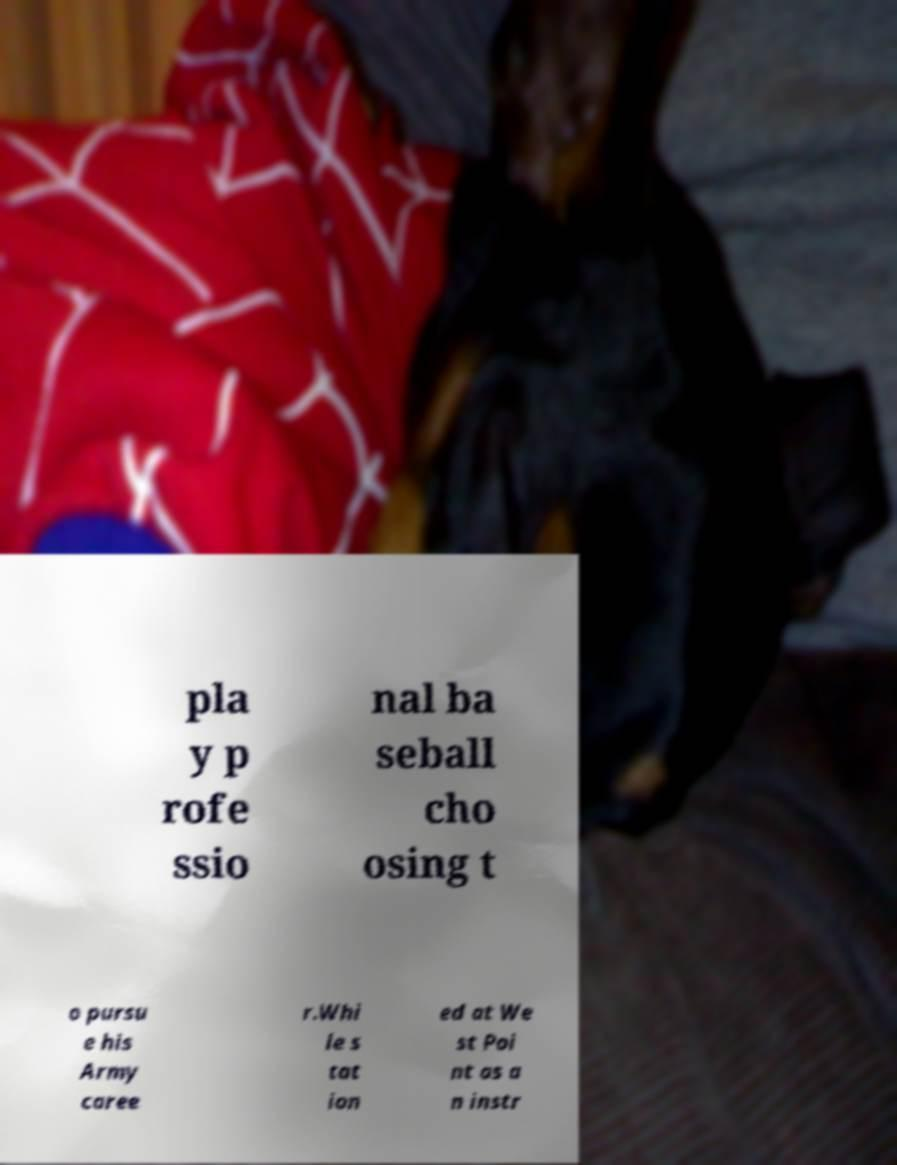Could you assist in decoding the text presented in this image and type it out clearly? pla y p rofe ssio nal ba seball cho osing t o pursu e his Army caree r.Whi le s tat ion ed at We st Poi nt as a n instr 